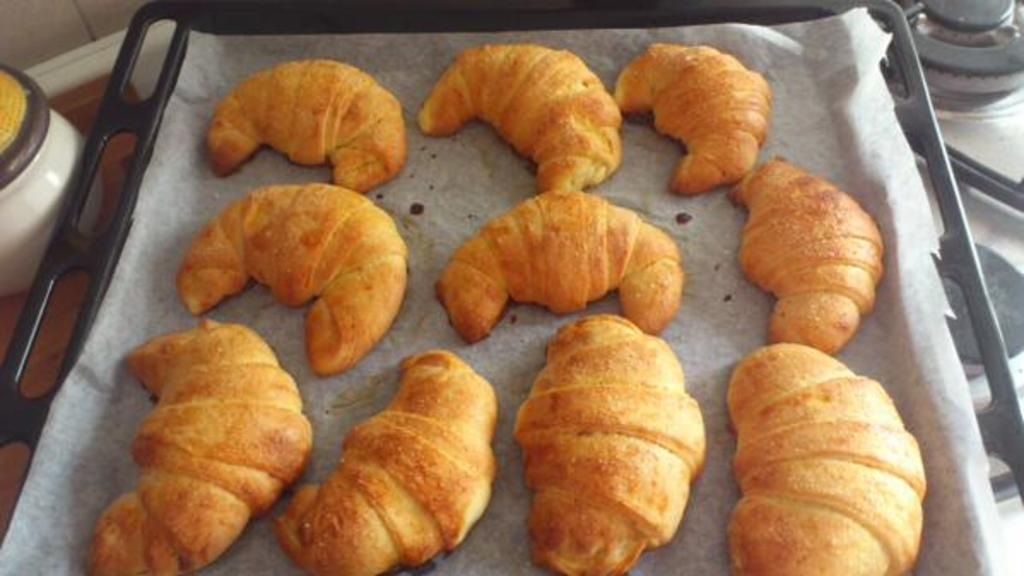What is the main subject of the image? There is a food item on a plate in the image. How many fish are present in the image? There is no fish present in the image; it only features a food item on a plate. What scientific discovery is depicted in the image? There is no scientific discovery depicted in the image; it only features a food item on a plate. 